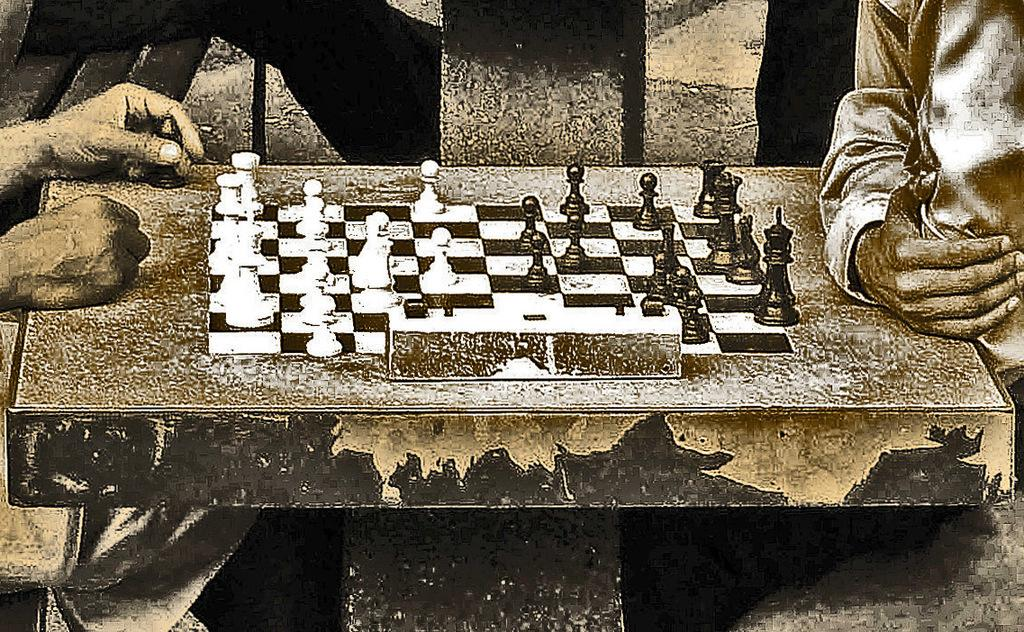What is the main object on the table in the image? There is a chess board on the table in the image. What is placed on the chess board? Chess pieces are present on the chess board. Can you describe the hands visible in the image? There are hands of people visible in the image, which suggests that they might be playing chess. What other objects can be seen in the image besides the chess board and pieces? There are other objects in the image, but their specific details are not mentioned in the provided facts. How many ladybugs are crawling on the chess board in the image? There are no ladybugs present on the chess board in the image. What type of dress is the lady wearing while playing chess in the image? There is no lady wearing a dress in the image; the hands visible in the image suggest that people might be playing chess, but their clothing is not mentioned in the provided facts. 